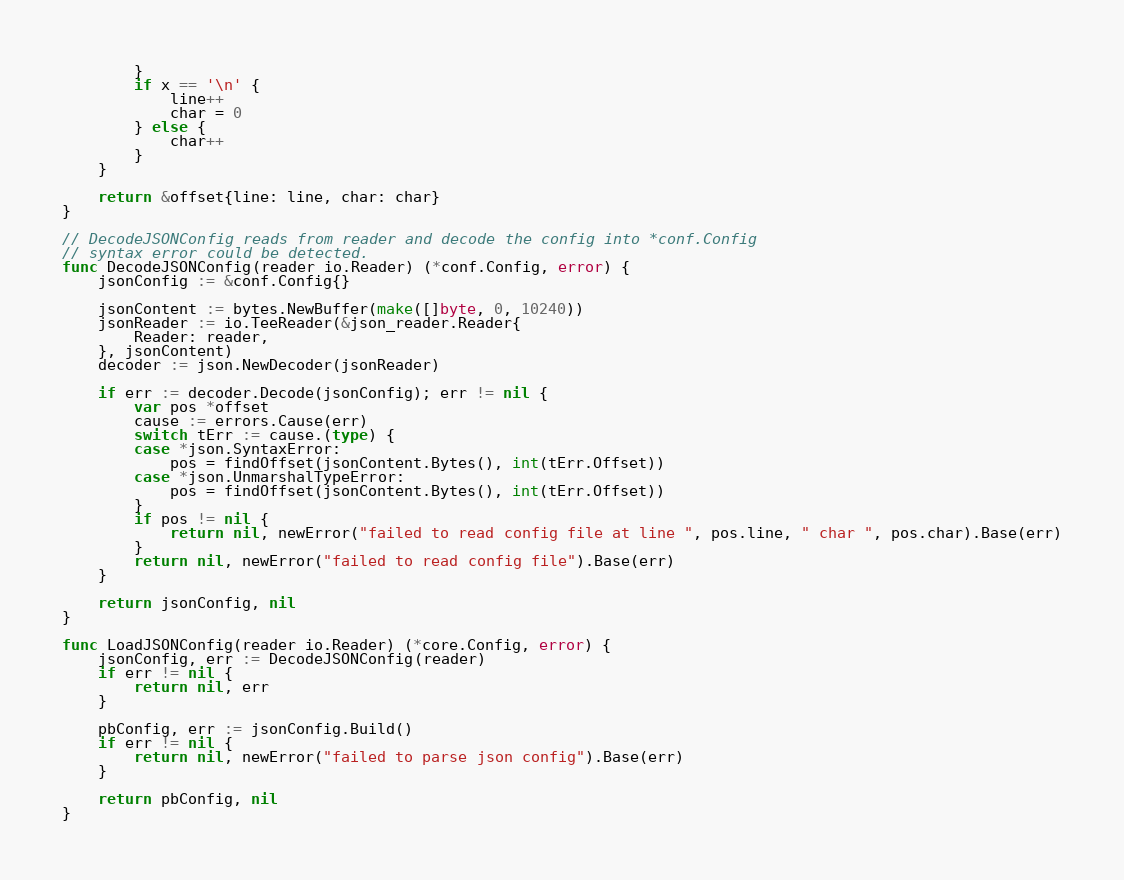Convert code to text. <code><loc_0><loc_0><loc_500><loc_500><_Go_>		}
		if x == '\n' {
			line++
			char = 0
		} else {
			char++
		}
	}

	return &offset{line: line, char: char}
}

// DecodeJSONConfig reads from reader and decode the config into *conf.Config
// syntax error could be detected.
func DecodeJSONConfig(reader io.Reader) (*conf.Config, error) {
	jsonConfig := &conf.Config{}

	jsonContent := bytes.NewBuffer(make([]byte, 0, 10240))
	jsonReader := io.TeeReader(&json_reader.Reader{
		Reader: reader,
	}, jsonContent)
	decoder := json.NewDecoder(jsonReader)

	if err := decoder.Decode(jsonConfig); err != nil {
		var pos *offset
		cause := errors.Cause(err)
		switch tErr := cause.(type) {
		case *json.SyntaxError:
			pos = findOffset(jsonContent.Bytes(), int(tErr.Offset))
		case *json.UnmarshalTypeError:
			pos = findOffset(jsonContent.Bytes(), int(tErr.Offset))
		}
		if pos != nil {
			return nil, newError("failed to read config file at line ", pos.line, " char ", pos.char).Base(err)
		}
		return nil, newError("failed to read config file").Base(err)
	}

	return jsonConfig, nil
}

func LoadJSONConfig(reader io.Reader) (*core.Config, error) {
	jsonConfig, err := DecodeJSONConfig(reader)
	if err != nil {
		return nil, err
	}

	pbConfig, err := jsonConfig.Build()
	if err != nil {
		return nil, newError("failed to parse json config").Base(err)
	}

	return pbConfig, nil
}
</code> 